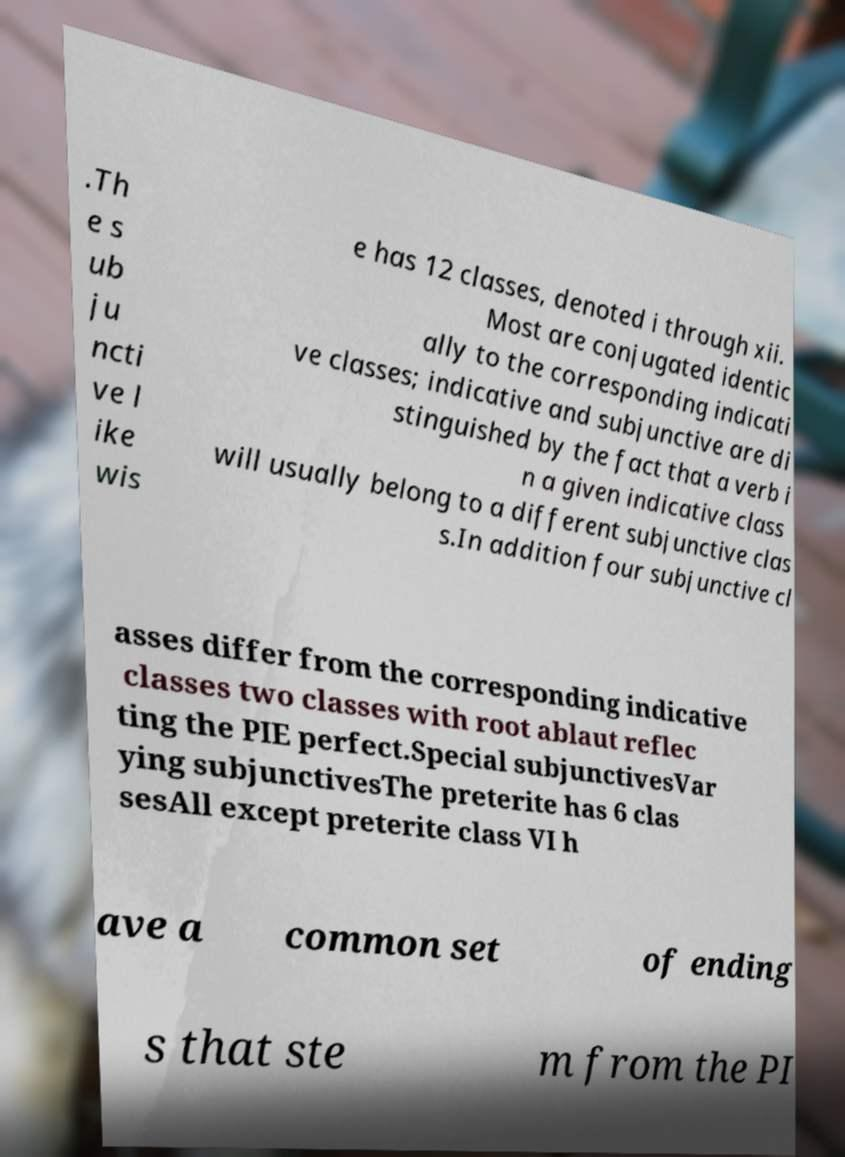What messages or text are displayed in this image? I need them in a readable, typed format. .Th e s ub ju ncti ve l ike wis e has 12 classes, denoted i through xii. Most are conjugated identic ally to the corresponding indicati ve classes; indicative and subjunctive are di stinguished by the fact that a verb i n a given indicative class will usually belong to a different subjunctive clas s.In addition four subjunctive cl asses differ from the corresponding indicative classes two classes with root ablaut reflec ting the PIE perfect.Special subjunctivesVar ying subjunctivesThe preterite has 6 clas sesAll except preterite class VI h ave a common set of ending s that ste m from the PI 